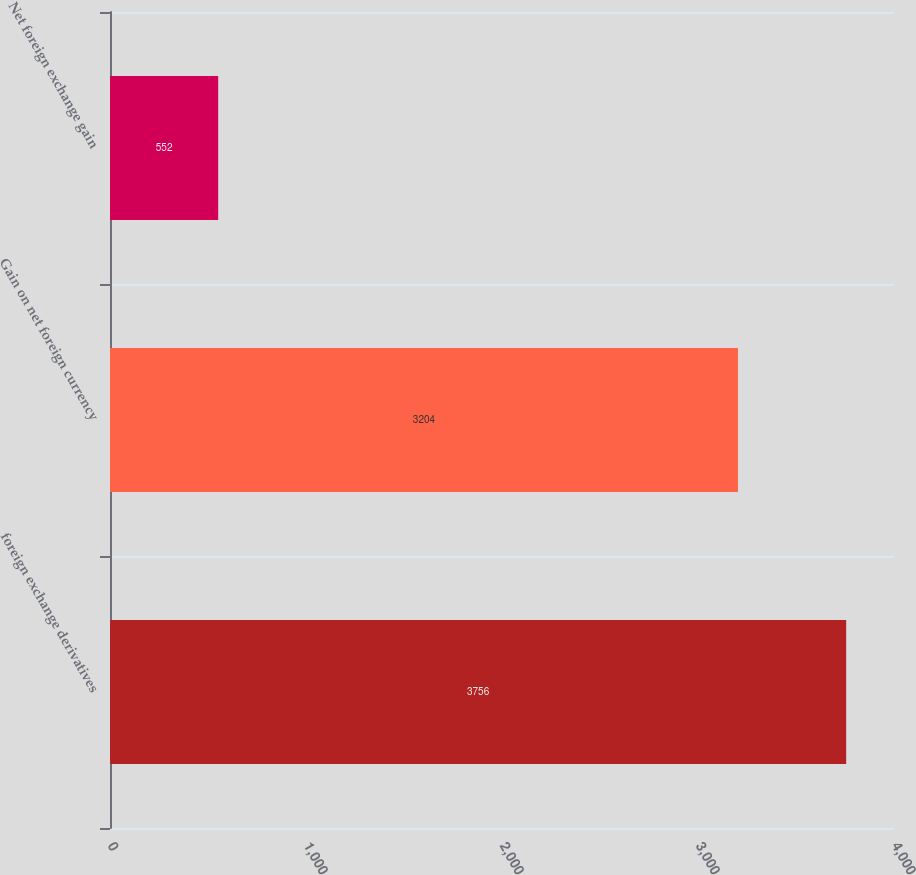Convert chart to OTSL. <chart><loc_0><loc_0><loc_500><loc_500><bar_chart><fcel>foreign exchange derivatives<fcel>Gain on net foreign currency<fcel>Net foreign exchange gain<nl><fcel>3756<fcel>3204<fcel>552<nl></chart> 